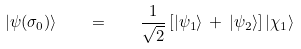<formula> <loc_0><loc_0><loc_500><loc_500>| \psi ( \sigma _ { 0 } ) \rangle \quad = \quad \frac { 1 } { \sqrt { 2 } } \, [ | \psi _ { 1 } \rangle \, + \, | \psi _ { 2 } \rangle ] \, | \chi _ { 1 } \rangle</formula> 